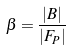Convert formula to latex. <formula><loc_0><loc_0><loc_500><loc_500>\beta = \frac { | B | } { | F _ { P } | }</formula> 